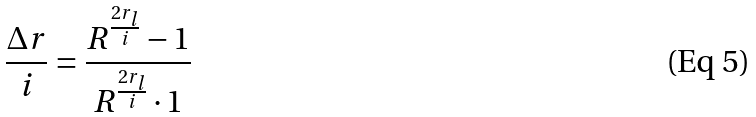Convert formula to latex. <formula><loc_0><loc_0><loc_500><loc_500>\frac { \Delta r } { i } = \frac { R ^ { \frac { 2 r _ { l } } { i } } - 1 } { R ^ { \frac { 2 r _ { l } } { i } } \cdot 1 }</formula> 